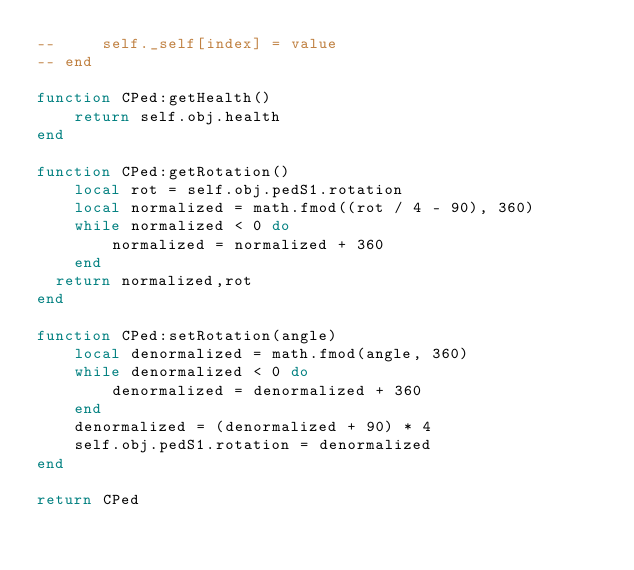Convert code to text. <code><loc_0><loc_0><loc_500><loc_500><_Lua_>--     self._self[index] = value
-- end

function CPed:getHealth()
    return self.obj.health
end

function CPed:getRotation()
    local rot = self.obj.pedS1.rotation
    local normalized = math.fmod((rot / 4 - 90), 360)
    while normalized < 0 do
        normalized = normalized + 360
    end
	return normalized,rot
end

function CPed:setRotation(angle)
    local denormalized = math.fmod(angle, 360)
    while denormalized < 0 do
        denormalized = denormalized + 360
    end
    denormalized = (denormalized + 90) * 4
    self.obj.pedS1.rotation = denormalized
end

return CPed
</code> 